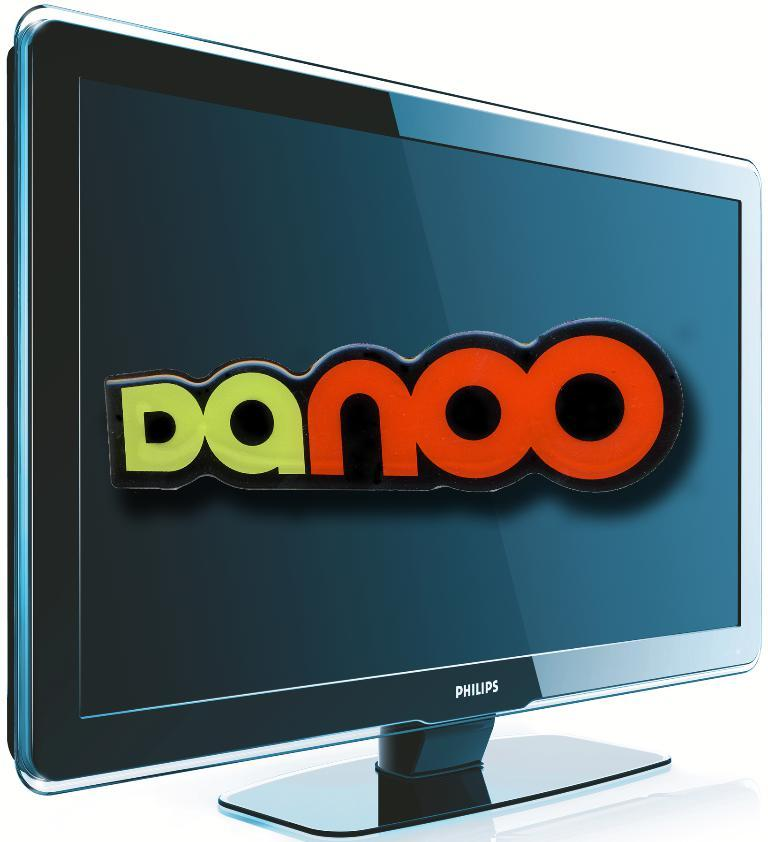<image>
Offer a succinct explanation of the picture presented. A Philips monitor shows the word "danoo" on it. 